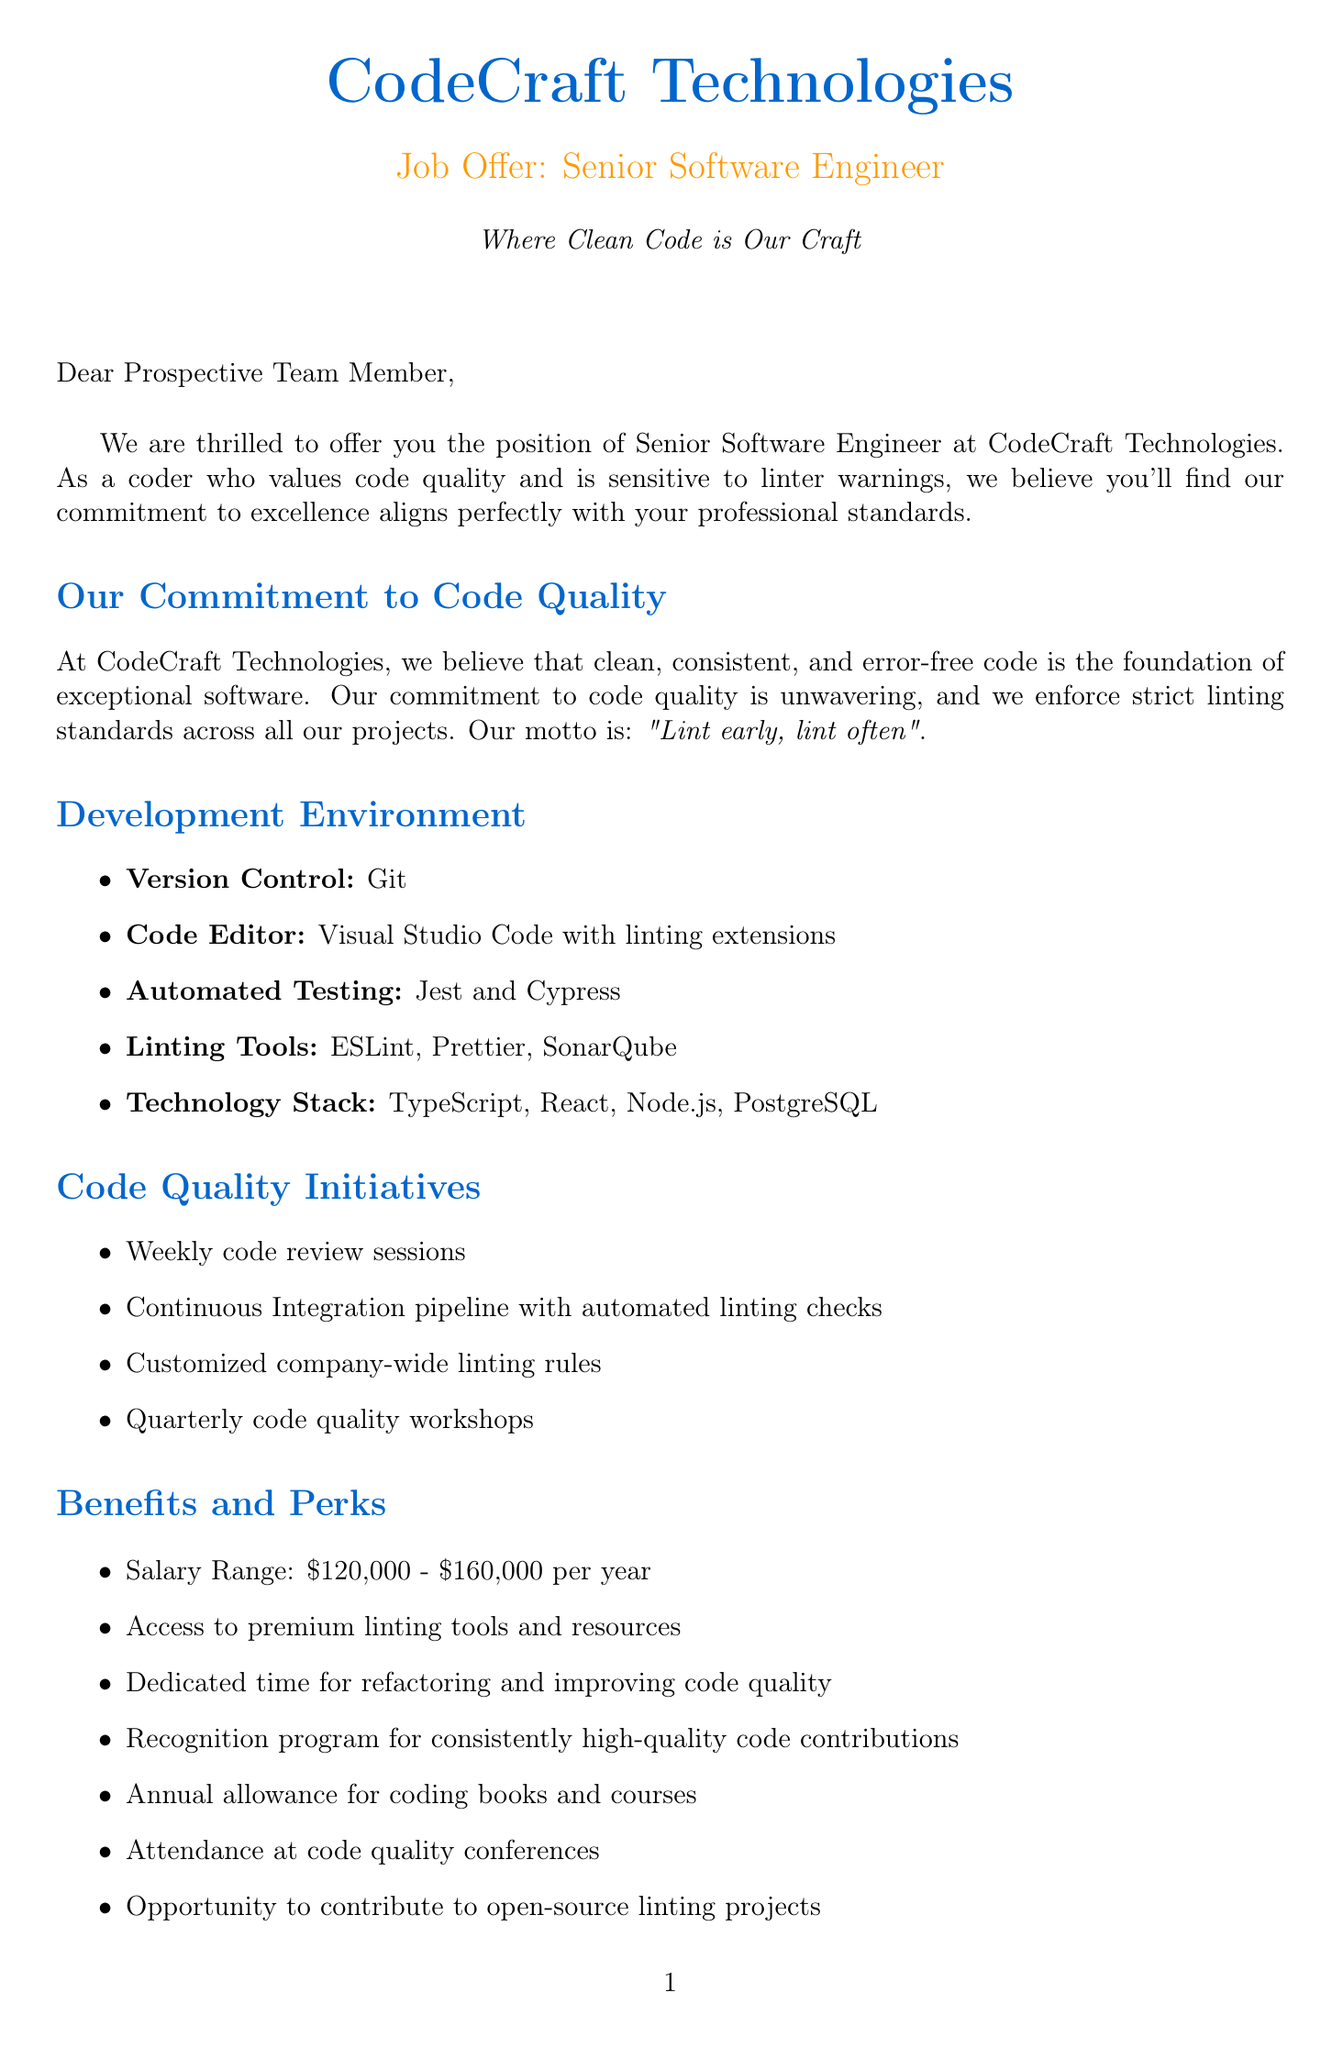What is the company name? The company name is stated at the beginning of the document as the title of the letter.
Answer: CodeCraft Technologies What is the position offered in the letter? The position is highlighted in the title of the job offer section.
Answer: Senior Software Engineer What is the salary range for the position? The salary range is mentioned under the benefits section of the document.
Answer: $120,000 - $160,000 per year What is the probation period duration? The probation period is specified along with the focus of this period in the document.
Answer: 3 months Who is the contact person mentioned in the letter? The contact person's name and position are detailed towards the end of the letter.
Answer: Emily Chen What is the development environment code editor mentioned? The code editor used in the development environment is listed in the environment section.
Answer: Visual Studio Code with linting extensions What code quality motto does the company have? The company motto regarding code quality is outlined in the team culture section.
Answer: Lint early, lint often Which automated testing tools are used at CodeCraft Technologies? The automated testing tools are specified in the development environment section.
Answer: Jest and Cypress What recognition did the company achieve in 2023? The document states the achievement in the company achievements section.
Answer: Top Tech Employer for Code Quality by TechCrunch What is the start date for the new hire? The start date is mentioned in the next steps section of the document.
Answer: September 1, 2023 